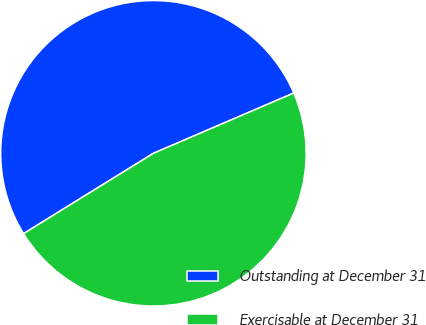<chart> <loc_0><loc_0><loc_500><loc_500><pie_chart><fcel>Outstanding at December 31<fcel>Exercisable at December 31<nl><fcel>52.36%<fcel>47.64%<nl></chart> 